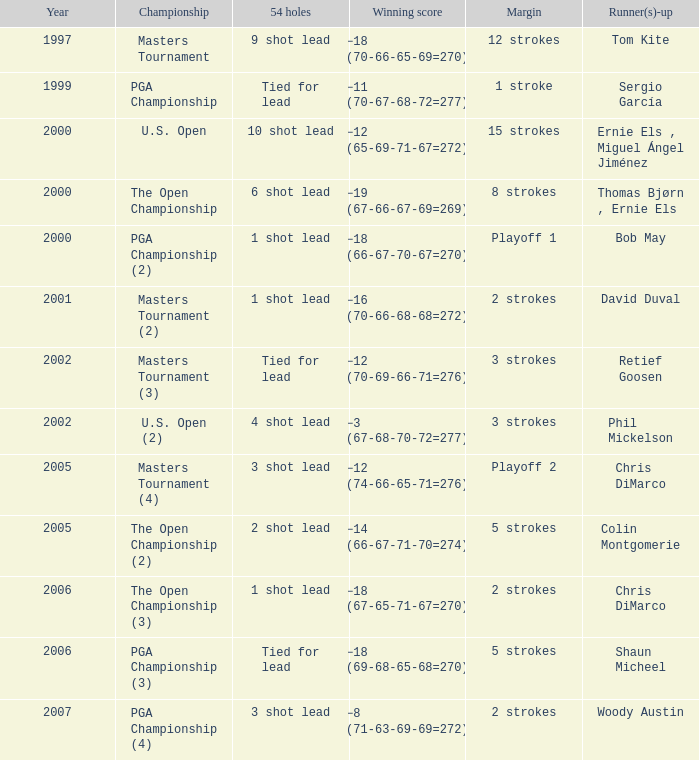 who is the runner(s)-up where 54 holes is tied for lead and margin is 5 strokes Shaun Micheel. 